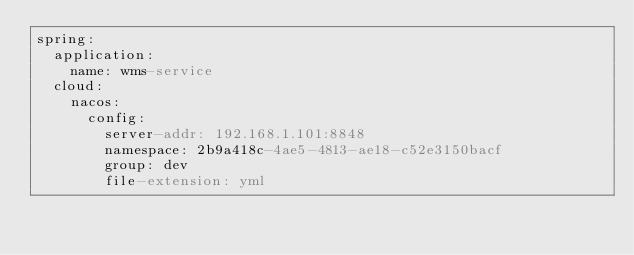Convert code to text. <code><loc_0><loc_0><loc_500><loc_500><_YAML_>spring:
  application:
    name: wms-service
  cloud:
    nacos:
      config:
        server-addr: 192.168.1.101:8848
        namespace: 2b9a418c-4ae5-4813-ae18-c52e3150bacf
        group: dev
        file-extension: yml</code> 